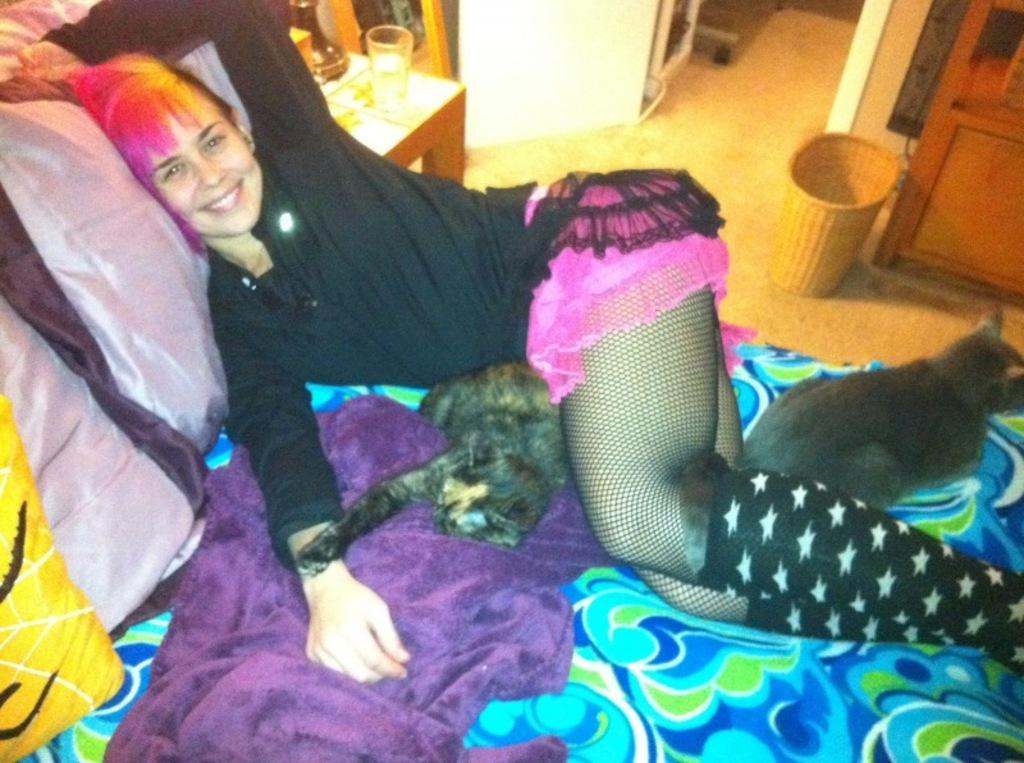Who is present in the image? There is a woman in the image. What is the woman doing in the image? The woman is lying on the bed. What is the woman's facial expression in the image? The woman is smiling. How many cats are on the bed with the woman? There are 2 cats on the bed. What can be seen in the background of the image? There is a table in the background of the image. What is on the table in the image? There is a glass on the table. What type of feast is being prepared on the chair in the image? There is no chair or feast present in the image. How does the water affect the woman's mood in the image? There is no water present in the image, so its effect on the woman's mood cannot be determined. 